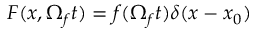Convert formula to latex. <formula><loc_0><loc_0><loc_500><loc_500>F ( x , \Omega _ { f } t ) = f ( \Omega _ { f } t ) \delta ( x - x _ { 0 } )</formula> 